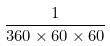<formula> <loc_0><loc_0><loc_500><loc_500>\frac { 1 } { 3 6 0 \times 6 0 \times 6 0 }</formula> 